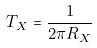Convert formula to latex. <formula><loc_0><loc_0><loc_500><loc_500>T _ { X } = \frac { 1 } { 2 \pi R _ { X } }</formula> 